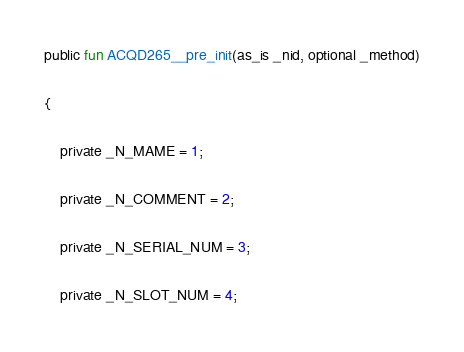<code> <loc_0><loc_0><loc_500><loc_500><_SML_>public fun ACQD265__pre_init(as_is _nid, optional _method)

{

    private _N_MAME = 1;

    private _N_COMMENT = 2;

    private _N_SERIAL_NUM = 3;

    private _N_SLOT_NUM = 4;
</code> 